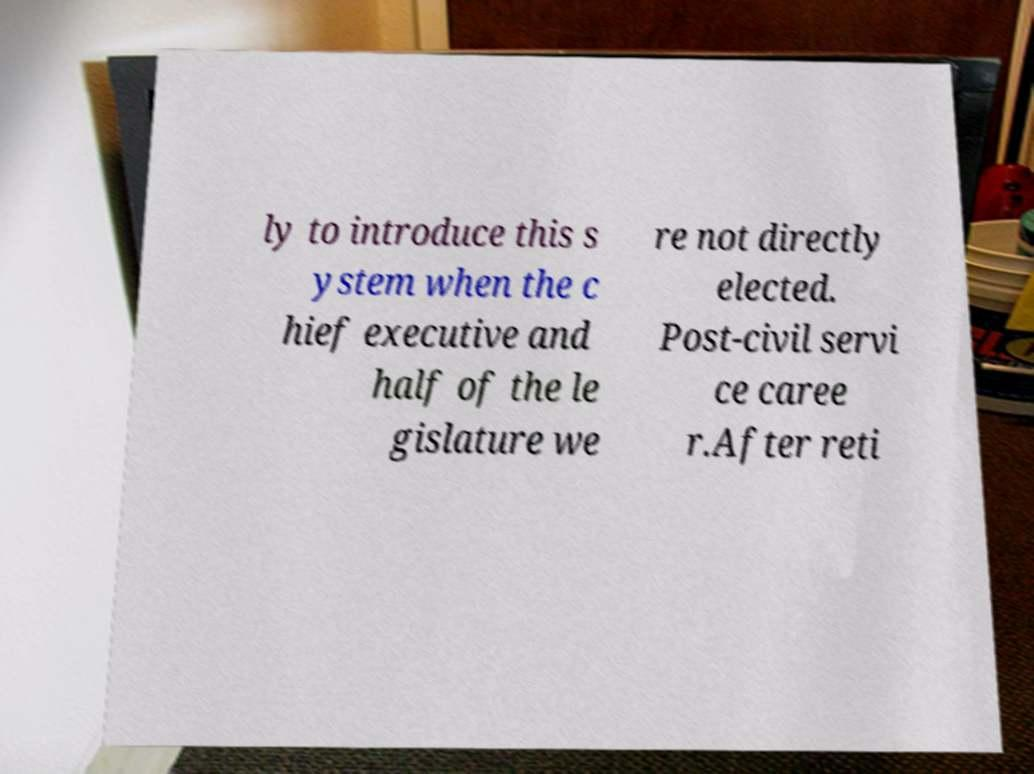For documentation purposes, I need the text within this image transcribed. Could you provide that? ly to introduce this s ystem when the c hief executive and half of the le gislature we re not directly elected. Post-civil servi ce caree r.After reti 